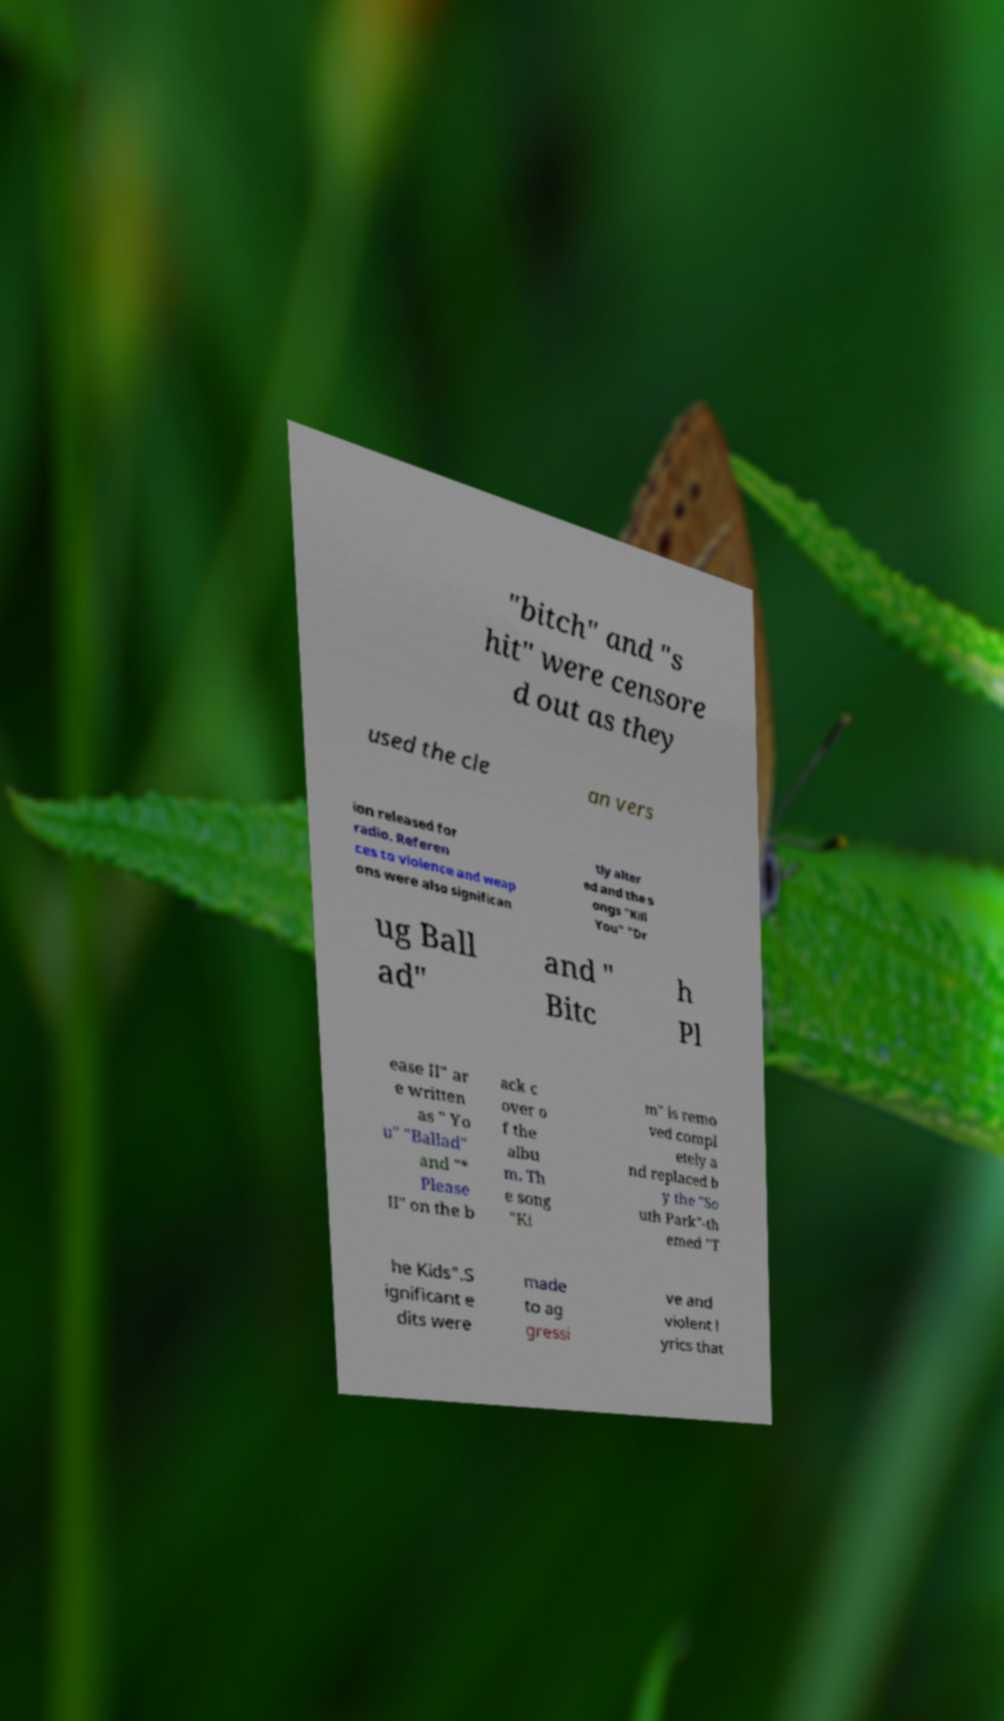Could you assist in decoding the text presented in this image and type it out clearly? "bitch" and "s hit" were censore d out as they used the cle an vers ion released for radio. Referen ces to violence and weap ons were also significan tly alter ed and the s ongs "Kill You" "Dr ug Ball ad" and " Bitc h Pl ease II" ar e written as " Yo u" "Ballad" and "* Please II" on the b ack c over o f the albu m. Th e song "Ki m" is remo ved compl etely a nd replaced b y the "So uth Park"-th emed "T he Kids".S ignificant e dits were made to ag gressi ve and violent l yrics that 